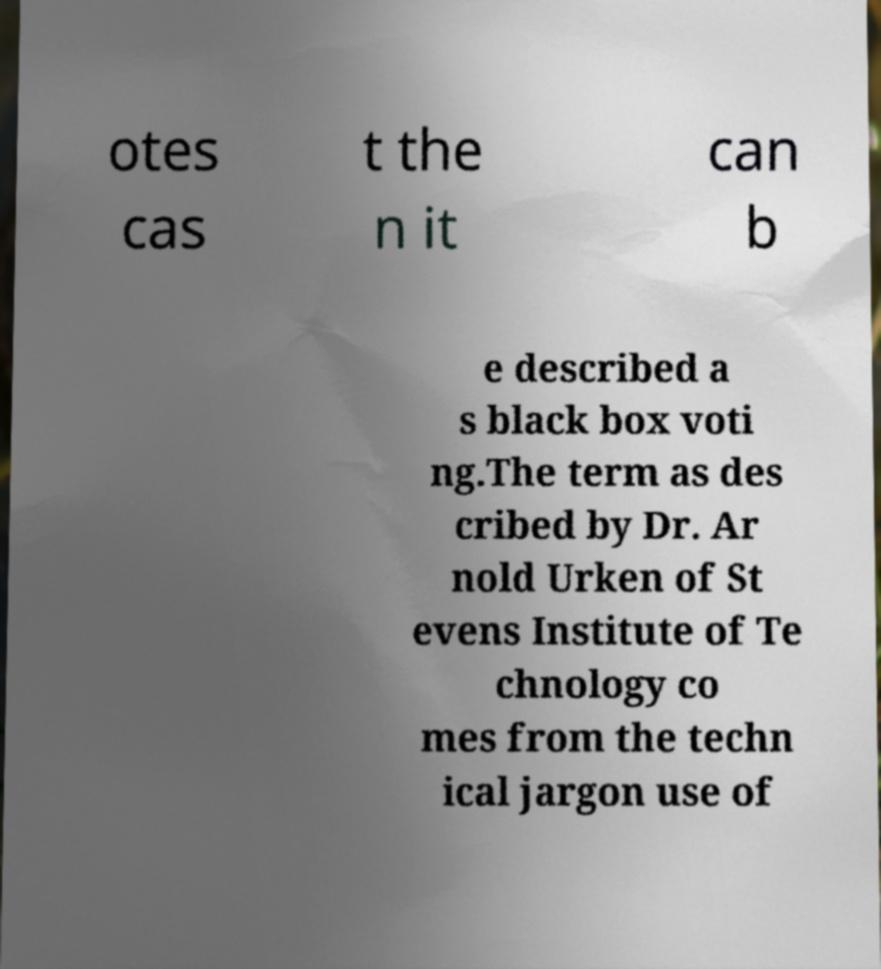Could you assist in decoding the text presented in this image and type it out clearly? otes cas t the n it can b e described a s black box voti ng.The term as des cribed by Dr. Ar nold Urken of St evens Institute of Te chnology co mes from the techn ical jargon use of 